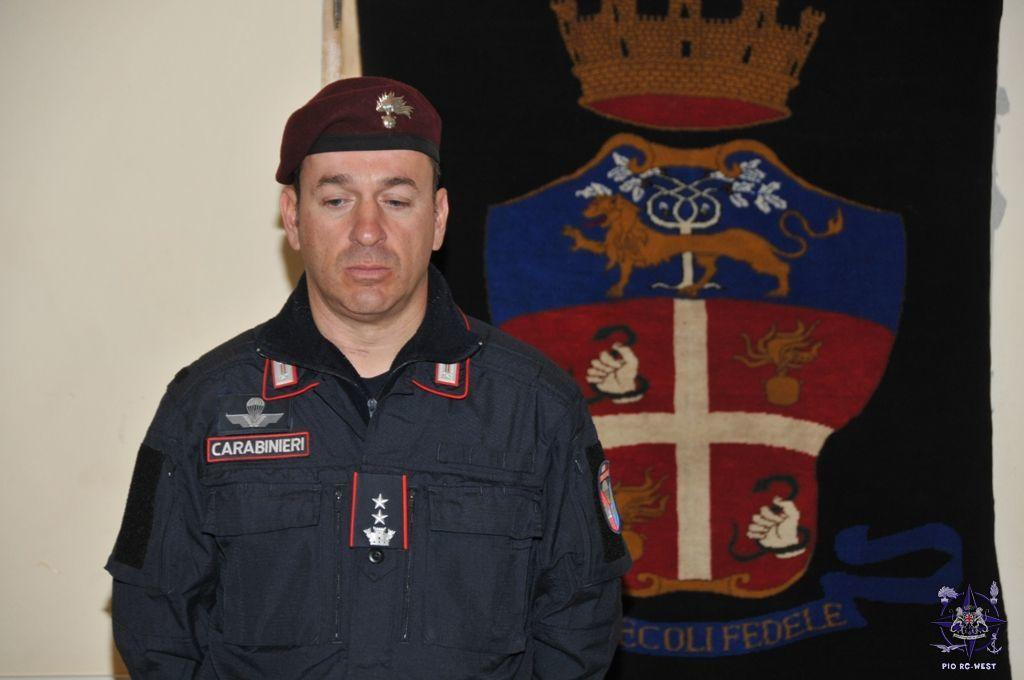Who is in the image? There is a man in the image. What is the man wearing on his head? The man is wearing a cap. What is on the man's shirt? The man is wearing a shirt with a badge symbol. What can be seen in the background of the image? There is a frame in the background of the image, and a wall. What is inside the frame? The frame contains a crown, lion, and hand, as well as other symbols. What time of day is it in the image? The time of day cannot be determined from the image, as there are no clues or indications of the time. 